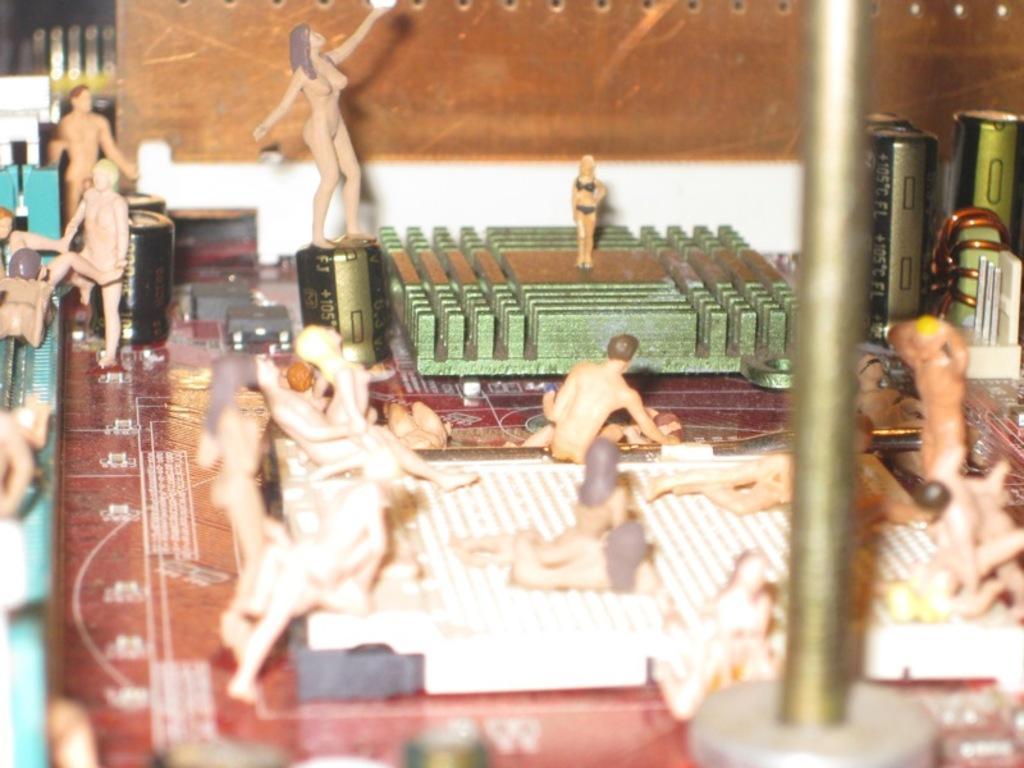In one or two sentences, can you explain what this image depicts? In this image we can see few toys, batteries, a metal rod and few other objects. 